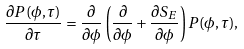<formula> <loc_0><loc_0><loc_500><loc_500>\frac { \partial P ( \phi , \tau ) } { \partial \tau } = \frac { \partial } { \partial \phi } \left ( \frac { \partial } { \partial \phi } + \frac { \partial S _ { E } } { \partial \phi } \right ) P ( \phi , \tau ) ,</formula> 